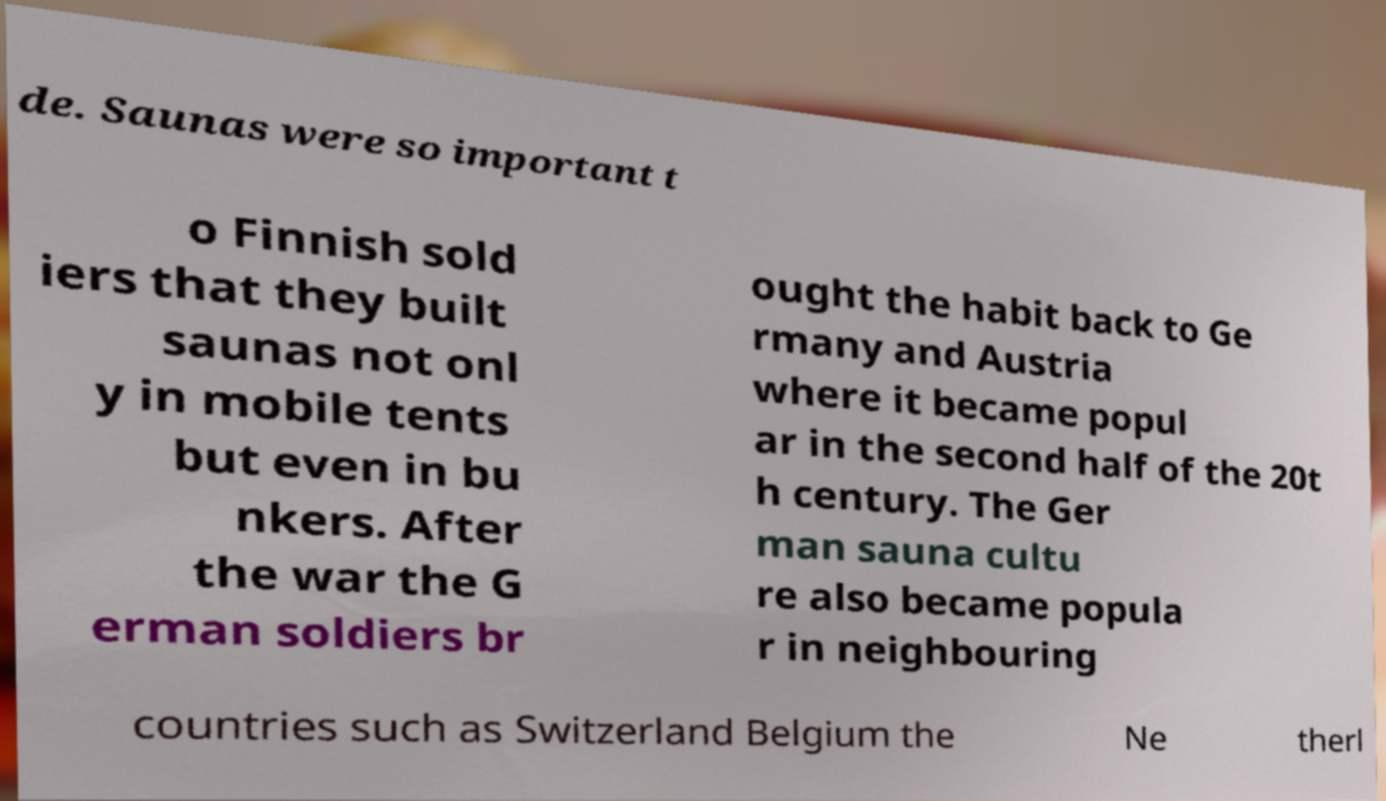Can you read and provide the text displayed in the image?This photo seems to have some interesting text. Can you extract and type it out for me? de. Saunas were so important t o Finnish sold iers that they built saunas not onl y in mobile tents but even in bu nkers. After the war the G erman soldiers br ought the habit back to Ge rmany and Austria where it became popul ar in the second half of the 20t h century. The Ger man sauna cultu re also became popula r in neighbouring countries such as Switzerland Belgium the Ne therl 